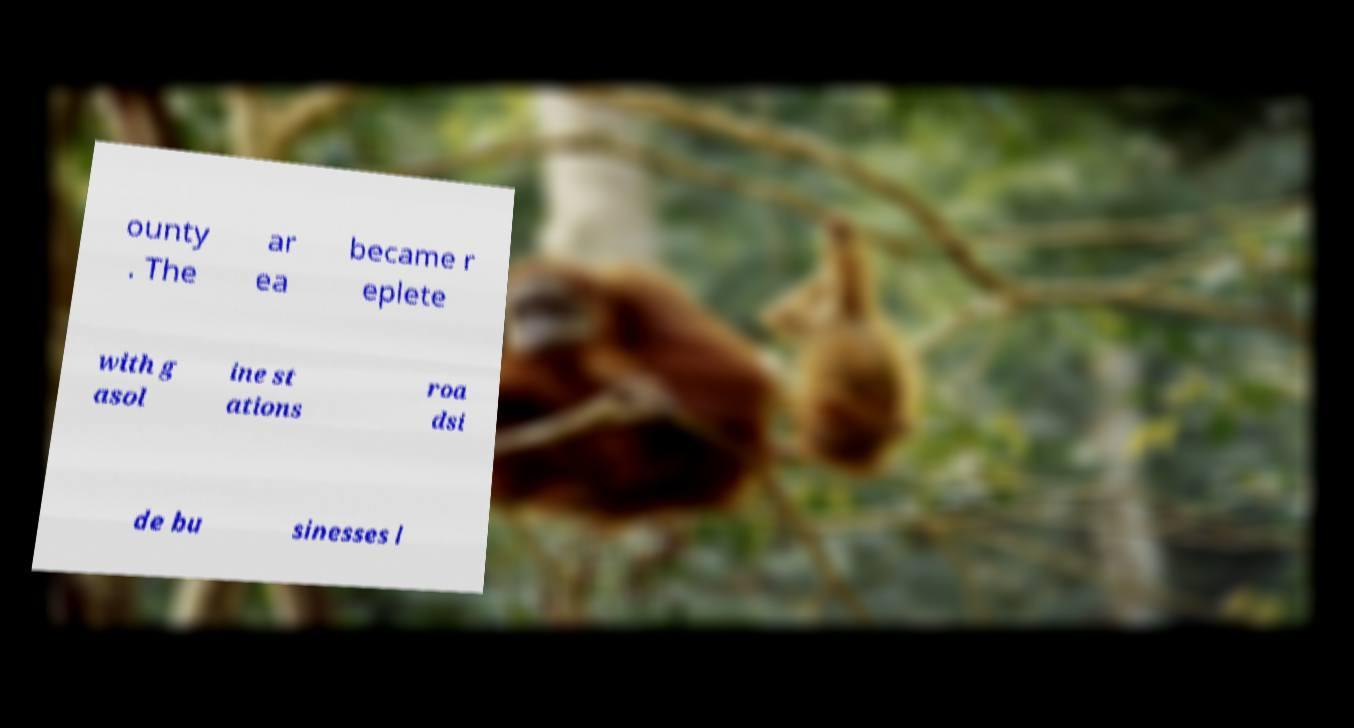I need the written content from this picture converted into text. Can you do that? ounty . The ar ea became r eplete with g asol ine st ations roa dsi de bu sinesses l 